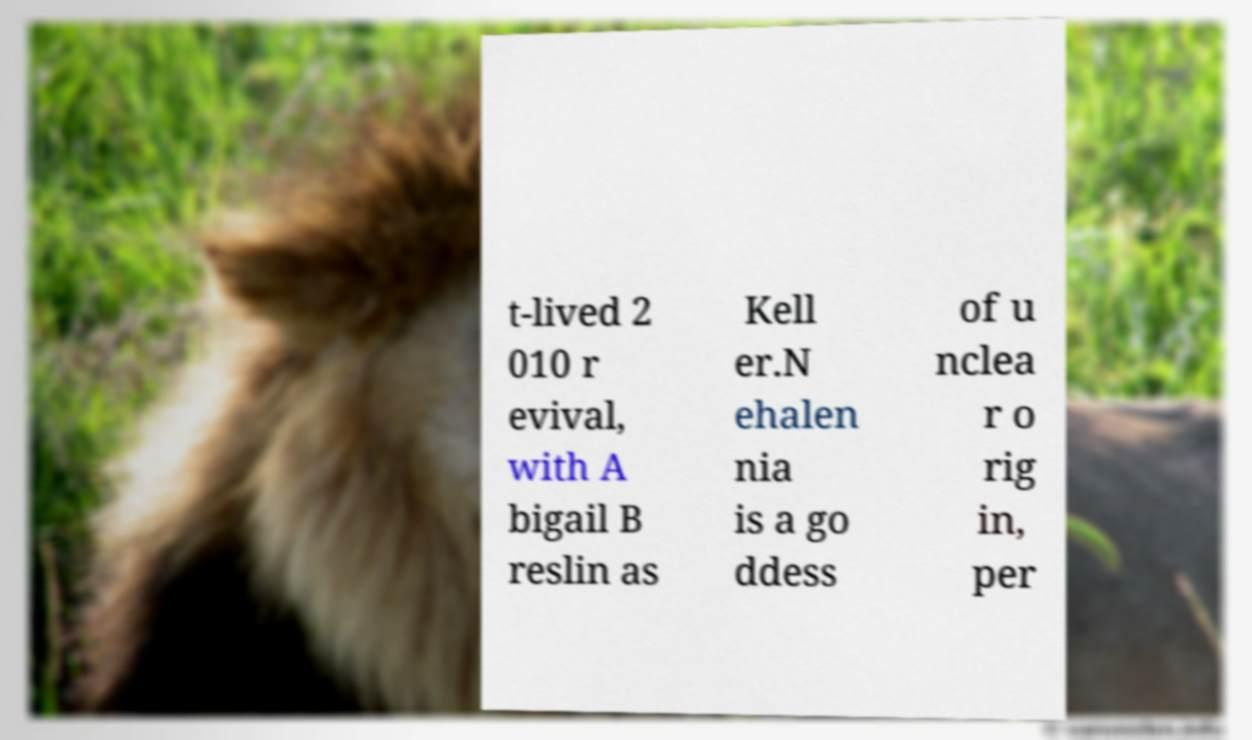Can you read and provide the text displayed in the image?This photo seems to have some interesting text. Can you extract and type it out for me? t-lived 2 010 r evival, with A bigail B reslin as Kell er.N ehalen nia is a go ddess of u nclea r o rig in, per 